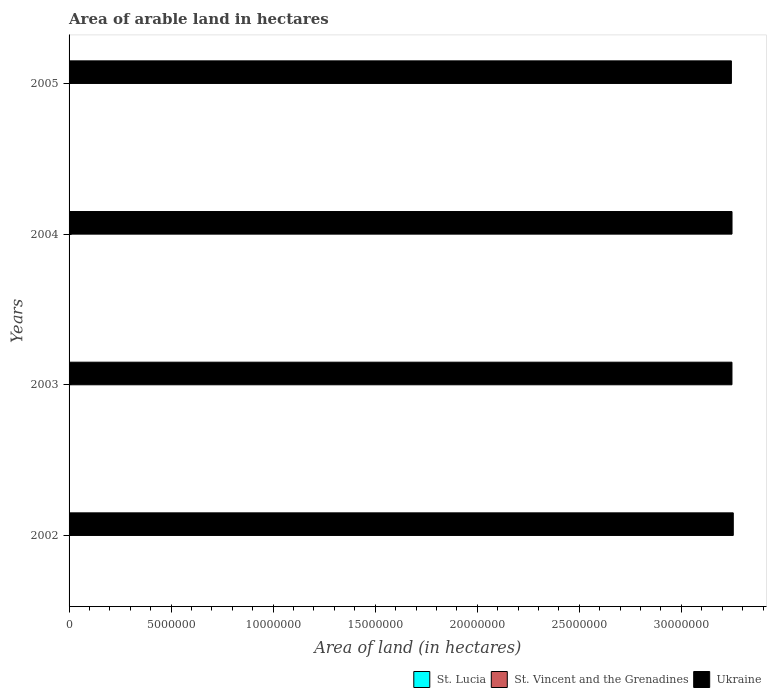How many different coloured bars are there?
Offer a terse response. 3. Are the number of bars per tick equal to the number of legend labels?
Provide a succinct answer. Yes. Are the number of bars on each tick of the Y-axis equal?
Offer a terse response. Yes. How many bars are there on the 4th tick from the top?
Keep it short and to the point. 3. How many bars are there on the 1st tick from the bottom?
Offer a very short reply. 3. What is the label of the 2nd group of bars from the top?
Make the answer very short. 2004. In how many cases, is the number of bars for a given year not equal to the number of legend labels?
Your answer should be very brief. 0. What is the total arable land in St. Lucia in 2003?
Your answer should be compact. 2000. Across all years, what is the maximum total arable land in St. Lucia?
Give a very brief answer. 2200. Across all years, what is the minimum total arable land in St. Lucia?
Provide a succinct answer. 2000. What is the total total arable land in Ukraine in the graph?
Provide a succinct answer. 1.30e+08. What is the difference between the total arable land in St. Lucia in 2004 and that in 2005?
Offer a very short reply. -200. What is the difference between the total arable land in St. Lucia in 2003 and the total arable land in Ukraine in 2002?
Your answer should be compact. -3.25e+07. What is the average total arable land in St. Lucia per year?
Provide a short and direct response. 2050. In the year 2002, what is the difference between the total arable land in St. Lucia and total arable land in St. Vincent and the Grenadines?
Offer a terse response. -3000. What is the ratio of the total arable land in St. Lucia in 2002 to that in 2003?
Your response must be concise. 1. Is the sum of the total arable land in Ukraine in 2002 and 2005 greater than the maximum total arable land in St. Lucia across all years?
Ensure brevity in your answer.  Yes. What does the 1st bar from the top in 2004 represents?
Provide a short and direct response. Ukraine. What does the 2nd bar from the bottom in 2005 represents?
Keep it short and to the point. St. Vincent and the Grenadines. Are all the bars in the graph horizontal?
Your response must be concise. Yes. Does the graph contain any zero values?
Your answer should be very brief. No. Does the graph contain grids?
Provide a short and direct response. No. Where does the legend appear in the graph?
Ensure brevity in your answer.  Bottom right. How many legend labels are there?
Make the answer very short. 3. What is the title of the graph?
Offer a very short reply. Area of arable land in hectares. What is the label or title of the X-axis?
Make the answer very short. Area of land (in hectares). What is the label or title of the Y-axis?
Offer a terse response. Years. What is the Area of land (in hectares) of St. Vincent and the Grenadines in 2002?
Provide a succinct answer. 5000. What is the Area of land (in hectares) in Ukraine in 2002?
Your response must be concise. 3.25e+07. What is the Area of land (in hectares) in Ukraine in 2003?
Give a very brief answer. 3.25e+07. What is the Area of land (in hectares) of St. Vincent and the Grenadines in 2004?
Give a very brief answer. 5000. What is the Area of land (in hectares) of Ukraine in 2004?
Keep it short and to the point. 3.25e+07. What is the Area of land (in hectares) in St. Lucia in 2005?
Offer a very short reply. 2200. What is the Area of land (in hectares) in Ukraine in 2005?
Ensure brevity in your answer.  3.25e+07. Across all years, what is the maximum Area of land (in hectares) in St. Lucia?
Make the answer very short. 2200. Across all years, what is the maximum Area of land (in hectares) of St. Vincent and the Grenadines?
Your answer should be compact. 5000. Across all years, what is the maximum Area of land (in hectares) of Ukraine?
Offer a very short reply. 3.25e+07. Across all years, what is the minimum Area of land (in hectares) in St. Lucia?
Ensure brevity in your answer.  2000. Across all years, what is the minimum Area of land (in hectares) of St. Vincent and the Grenadines?
Give a very brief answer. 5000. Across all years, what is the minimum Area of land (in hectares) of Ukraine?
Provide a short and direct response. 3.25e+07. What is the total Area of land (in hectares) of St. Lucia in the graph?
Give a very brief answer. 8200. What is the total Area of land (in hectares) of Ukraine in the graph?
Offer a very short reply. 1.30e+08. What is the difference between the Area of land (in hectares) in St. Lucia in 2002 and that in 2003?
Ensure brevity in your answer.  0. What is the difference between the Area of land (in hectares) in Ukraine in 2002 and that in 2003?
Give a very brief answer. 6.40e+04. What is the difference between the Area of land (in hectares) of Ukraine in 2002 and that in 2004?
Your answer should be very brief. 6.20e+04. What is the difference between the Area of land (in hectares) in St. Lucia in 2002 and that in 2005?
Give a very brief answer. -200. What is the difference between the Area of land (in hectares) of St. Vincent and the Grenadines in 2002 and that in 2005?
Your answer should be compact. 0. What is the difference between the Area of land (in hectares) in Ukraine in 2002 and that in 2005?
Your answer should be compact. 9.20e+04. What is the difference between the Area of land (in hectares) in St. Vincent and the Grenadines in 2003 and that in 2004?
Keep it short and to the point. 0. What is the difference between the Area of land (in hectares) of Ukraine in 2003 and that in 2004?
Offer a very short reply. -2000. What is the difference between the Area of land (in hectares) of St. Lucia in 2003 and that in 2005?
Offer a very short reply. -200. What is the difference between the Area of land (in hectares) in St. Vincent and the Grenadines in 2003 and that in 2005?
Provide a succinct answer. 0. What is the difference between the Area of land (in hectares) of Ukraine in 2003 and that in 2005?
Give a very brief answer. 2.80e+04. What is the difference between the Area of land (in hectares) in St. Lucia in 2004 and that in 2005?
Your answer should be compact. -200. What is the difference between the Area of land (in hectares) in Ukraine in 2004 and that in 2005?
Provide a short and direct response. 3.00e+04. What is the difference between the Area of land (in hectares) in St. Lucia in 2002 and the Area of land (in hectares) in St. Vincent and the Grenadines in 2003?
Ensure brevity in your answer.  -3000. What is the difference between the Area of land (in hectares) in St. Lucia in 2002 and the Area of land (in hectares) in Ukraine in 2003?
Your answer should be very brief. -3.25e+07. What is the difference between the Area of land (in hectares) of St. Vincent and the Grenadines in 2002 and the Area of land (in hectares) of Ukraine in 2003?
Your answer should be compact. -3.25e+07. What is the difference between the Area of land (in hectares) of St. Lucia in 2002 and the Area of land (in hectares) of St. Vincent and the Grenadines in 2004?
Keep it short and to the point. -3000. What is the difference between the Area of land (in hectares) of St. Lucia in 2002 and the Area of land (in hectares) of Ukraine in 2004?
Make the answer very short. -3.25e+07. What is the difference between the Area of land (in hectares) in St. Vincent and the Grenadines in 2002 and the Area of land (in hectares) in Ukraine in 2004?
Ensure brevity in your answer.  -3.25e+07. What is the difference between the Area of land (in hectares) of St. Lucia in 2002 and the Area of land (in hectares) of St. Vincent and the Grenadines in 2005?
Provide a short and direct response. -3000. What is the difference between the Area of land (in hectares) in St. Lucia in 2002 and the Area of land (in hectares) in Ukraine in 2005?
Ensure brevity in your answer.  -3.24e+07. What is the difference between the Area of land (in hectares) in St. Vincent and the Grenadines in 2002 and the Area of land (in hectares) in Ukraine in 2005?
Provide a succinct answer. -3.24e+07. What is the difference between the Area of land (in hectares) in St. Lucia in 2003 and the Area of land (in hectares) in St. Vincent and the Grenadines in 2004?
Ensure brevity in your answer.  -3000. What is the difference between the Area of land (in hectares) in St. Lucia in 2003 and the Area of land (in hectares) in Ukraine in 2004?
Make the answer very short. -3.25e+07. What is the difference between the Area of land (in hectares) of St. Vincent and the Grenadines in 2003 and the Area of land (in hectares) of Ukraine in 2004?
Your response must be concise. -3.25e+07. What is the difference between the Area of land (in hectares) of St. Lucia in 2003 and the Area of land (in hectares) of St. Vincent and the Grenadines in 2005?
Keep it short and to the point. -3000. What is the difference between the Area of land (in hectares) of St. Lucia in 2003 and the Area of land (in hectares) of Ukraine in 2005?
Provide a succinct answer. -3.24e+07. What is the difference between the Area of land (in hectares) of St. Vincent and the Grenadines in 2003 and the Area of land (in hectares) of Ukraine in 2005?
Keep it short and to the point. -3.24e+07. What is the difference between the Area of land (in hectares) of St. Lucia in 2004 and the Area of land (in hectares) of St. Vincent and the Grenadines in 2005?
Keep it short and to the point. -3000. What is the difference between the Area of land (in hectares) in St. Lucia in 2004 and the Area of land (in hectares) in Ukraine in 2005?
Ensure brevity in your answer.  -3.24e+07. What is the difference between the Area of land (in hectares) in St. Vincent and the Grenadines in 2004 and the Area of land (in hectares) in Ukraine in 2005?
Your answer should be compact. -3.24e+07. What is the average Area of land (in hectares) in St. Lucia per year?
Offer a very short reply. 2050. What is the average Area of land (in hectares) in St. Vincent and the Grenadines per year?
Your answer should be very brief. 5000. What is the average Area of land (in hectares) of Ukraine per year?
Your response must be concise. 3.25e+07. In the year 2002, what is the difference between the Area of land (in hectares) of St. Lucia and Area of land (in hectares) of St. Vincent and the Grenadines?
Offer a terse response. -3000. In the year 2002, what is the difference between the Area of land (in hectares) in St. Lucia and Area of land (in hectares) in Ukraine?
Your answer should be very brief. -3.25e+07. In the year 2002, what is the difference between the Area of land (in hectares) of St. Vincent and the Grenadines and Area of land (in hectares) of Ukraine?
Offer a very short reply. -3.25e+07. In the year 2003, what is the difference between the Area of land (in hectares) in St. Lucia and Area of land (in hectares) in St. Vincent and the Grenadines?
Make the answer very short. -3000. In the year 2003, what is the difference between the Area of land (in hectares) of St. Lucia and Area of land (in hectares) of Ukraine?
Offer a very short reply. -3.25e+07. In the year 2003, what is the difference between the Area of land (in hectares) of St. Vincent and the Grenadines and Area of land (in hectares) of Ukraine?
Your response must be concise. -3.25e+07. In the year 2004, what is the difference between the Area of land (in hectares) of St. Lucia and Area of land (in hectares) of St. Vincent and the Grenadines?
Keep it short and to the point. -3000. In the year 2004, what is the difference between the Area of land (in hectares) in St. Lucia and Area of land (in hectares) in Ukraine?
Your answer should be compact. -3.25e+07. In the year 2004, what is the difference between the Area of land (in hectares) in St. Vincent and the Grenadines and Area of land (in hectares) in Ukraine?
Keep it short and to the point. -3.25e+07. In the year 2005, what is the difference between the Area of land (in hectares) in St. Lucia and Area of land (in hectares) in St. Vincent and the Grenadines?
Keep it short and to the point. -2800. In the year 2005, what is the difference between the Area of land (in hectares) in St. Lucia and Area of land (in hectares) in Ukraine?
Your answer should be compact. -3.24e+07. In the year 2005, what is the difference between the Area of land (in hectares) of St. Vincent and the Grenadines and Area of land (in hectares) of Ukraine?
Offer a terse response. -3.24e+07. What is the ratio of the Area of land (in hectares) of St. Lucia in 2002 to that in 2003?
Your answer should be compact. 1. What is the ratio of the Area of land (in hectares) in St. Lucia in 2002 to that in 2004?
Your answer should be compact. 1. What is the ratio of the Area of land (in hectares) of St. Vincent and the Grenadines in 2002 to that in 2004?
Keep it short and to the point. 1. What is the ratio of the Area of land (in hectares) of St. Lucia in 2002 to that in 2005?
Your response must be concise. 0.91. What is the ratio of the Area of land (in hectares) of St. Vincent and the Grenadines in 2002 to that in 2005?
Offer a terse response. 1. What is the ratio of the Area of land (in hectares) of Ukraine in 2002 to that in 2005?
Your response must be concise. 1. What is the ratio of the Area of land (in hectares) of St. Lucia in 2003 to that in 2004?
Your answer should be very brief. 1. What is the ratio of the Area of land (in hectares) of St. Vincent and the Grenadines in 2003 to that in 2004?
Ensure brevity in your answer.  1. What is the ratio of the Area of land (in hectares) in St. Lucia in 2003 to that in 2005?
Make the answer very short. 0.91. What is the ratio of the Area of land (in hectares) in Ukraine in 2003 to that in 2005?
Keep it short and to the point. 1. What is the ratio of the Area of land (in hectares) of St. Lucia in 2004 to that in 2005?
Provide a succinct answer. 0.91. What is the ratio of the Area of land (in hectares) in St. Vincent and the Grenadines in 2004 to that in 2005?
Keep it short and to the point. 1. What is the difference between the highest and the second highest Area of land (in hectares) of St. Vincent and the Grenadines?
Your answer should be very brief. 0. What is the difference between the highest and the second highest Area of land (in hectares) of Ukraine?
Offer a terse response. 6.20e+04. What is the difference between the highest and the lowest Area of land (in hectares) in St. Vincent and the Grenadines?
Offer a terse response. 0. What is the difference between the highest and the lowest Area of land (in hectares) of Ukraine?
Offer a terse response. 9.20e+04. 